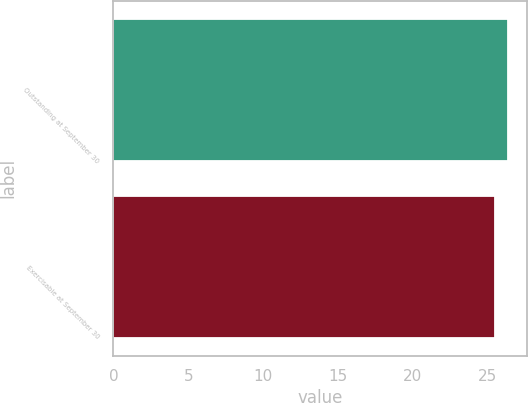<chart> <loc_0><loc_0><loc_500><loc_500><bar_chart><fcel>Outstanding at September 30<fcel>Exercisable at September 30<nl><fcel>26.32<fcel>25.5<nl></chart> 